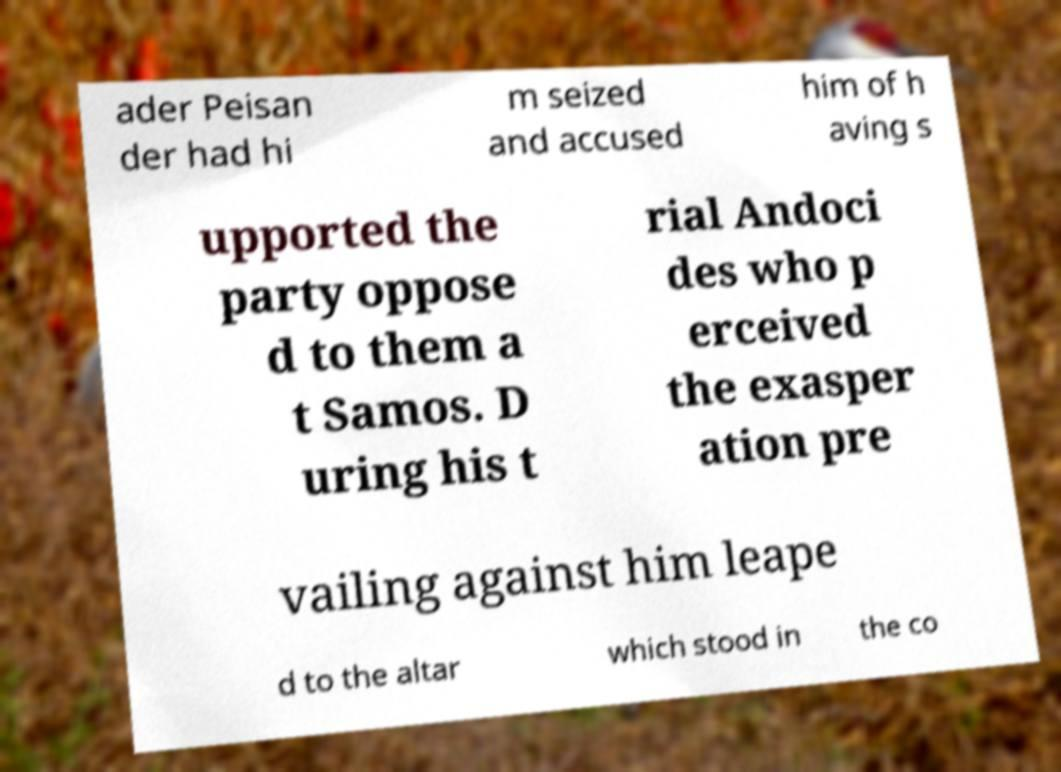What messages or text are displayed in this image? I need them in a readable, typed format. ader Peisan der had hi m seized and accused him of h aving s upported the party oppose d to them a t Samos. D uring his t rial Andoci des who p erceived the exasper ation pre vailing against him leape d to the altar which stood in the co 